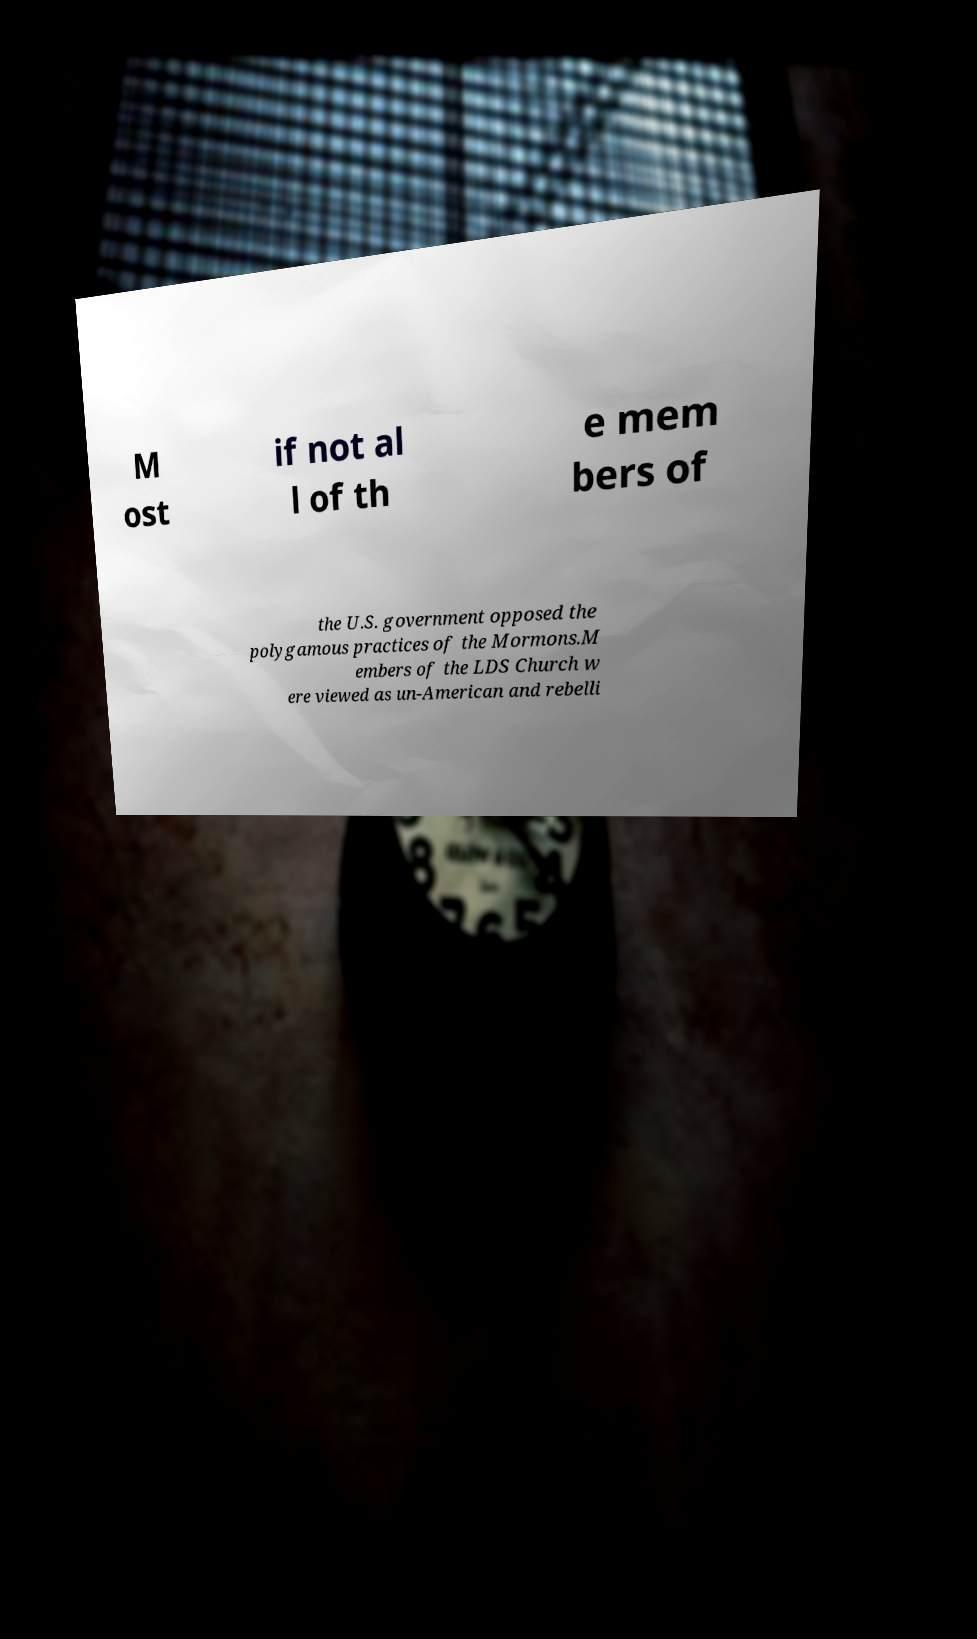Could you assist in decoding the text presented in this image and type it out clearly? M ost if not al l of th e mem bers of the U.S. government opposed the polygamous practices of the Mormons.M embers of the LDS Church w ere viewed as un-American and rebelli 